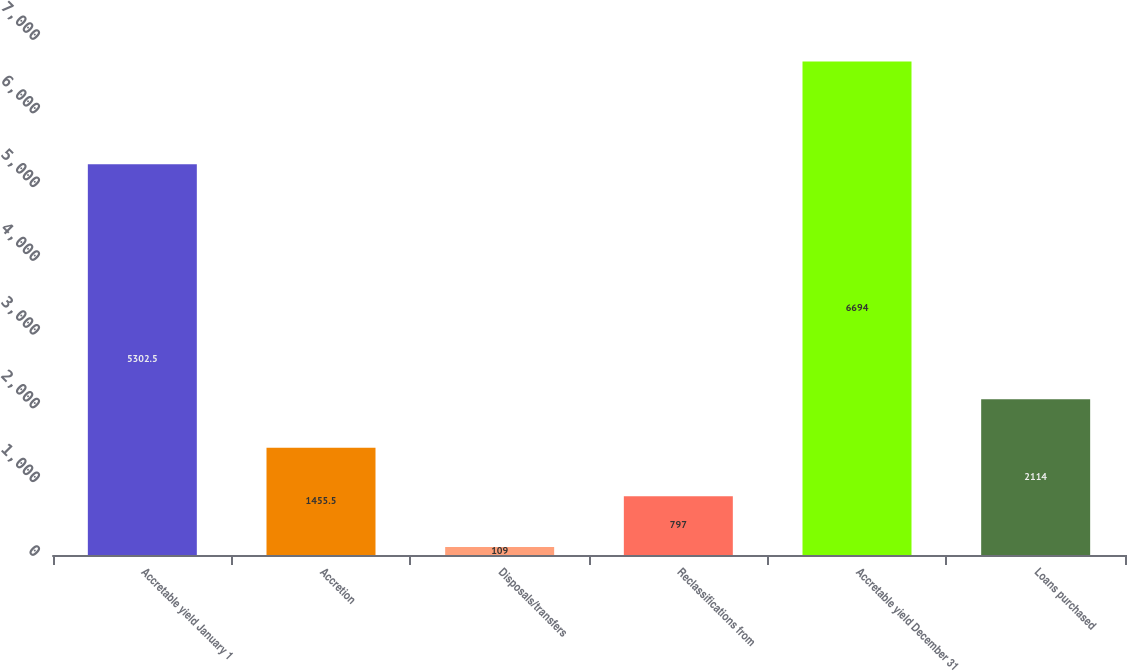Convert chart to OTSL. <chart><loc_0><loc_0><loc_500><loc_500><bar_chart><fcel>Accretable yield January 1<fcel>Accretion<fcel>Disposals/transfers<fcel>Reclassifications from<fcel>Accretable yield December 31<fcel>Loans purchased<nl><fcel>5302.5<fcel>1455.5<fcel>109<fcel>797<fcel>6694<fcel>2114<nl></chart> 